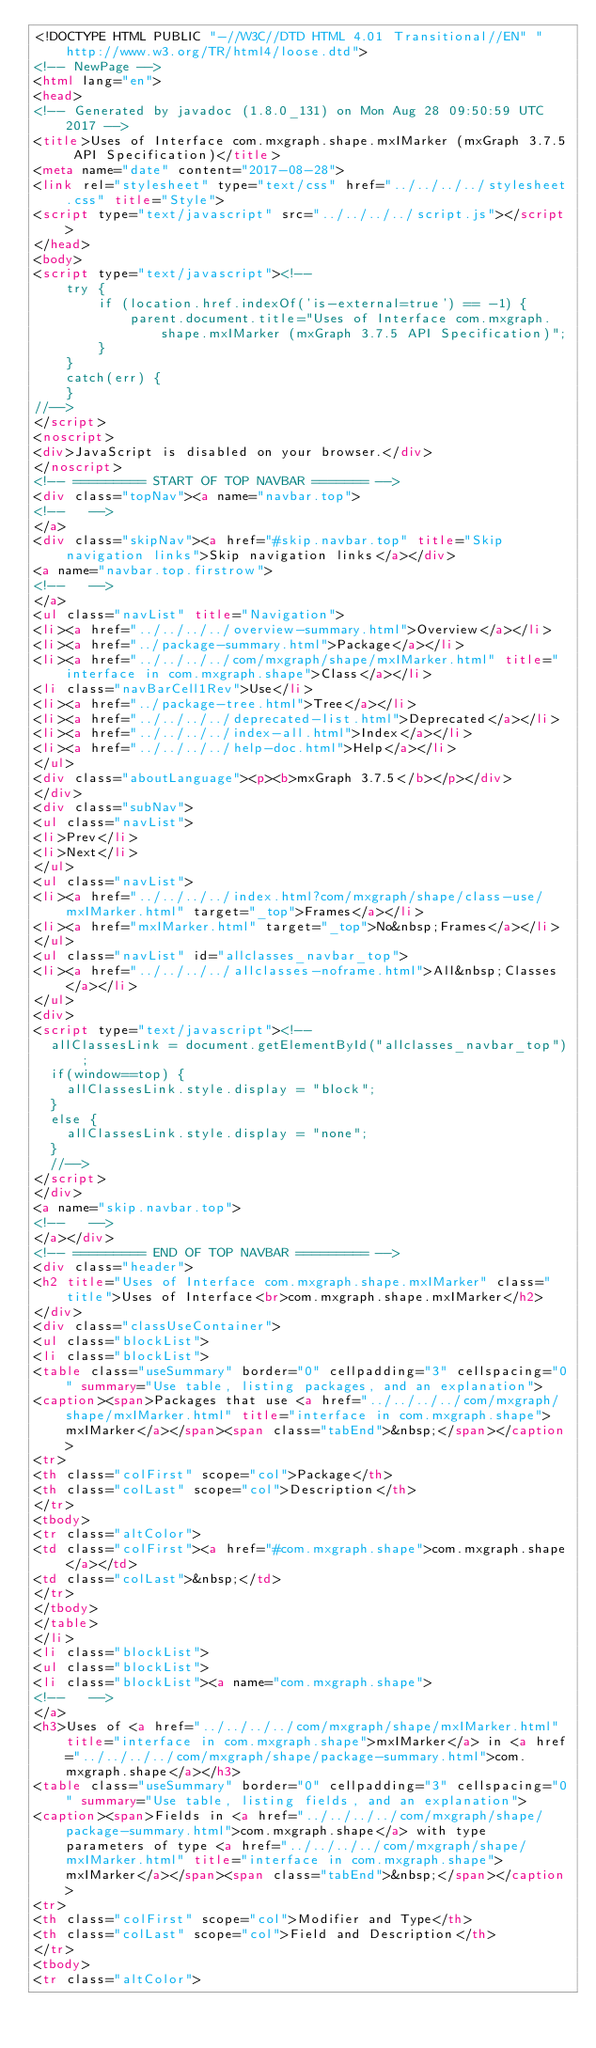Convert code to text. <code><loc_0><loc_0><loc_500><loc_500><_HTML_><!DOCTYPE HTML PUBLIC "-//W3C//DTD HTML 4.01 Transitional//EN" "http://www.w3.org/TR/html4/loose.dtd">
<!-- NewPage -->
<html lang="en">
<head>
<!-- Generated by javadoc (1.8.0_131) on Mon Aug 28 09:50:59 UTC 2017 -->
<title>Uses of Interface com.mxgraph.shape.mxIMarker (mxGraph 3.7.5 API Specification)</title>
<meta name="date" content="2017-08-28">
<link rel="stylesheet" type="text/css" href="../../../../stylesheet.css" title="Style">
<script type="text/javascript" src="../../../../script.js"></script>
</head>
<body>
<script type="text/javascript"><!--
    try {
        if (location.href.indexOf('is-external=true') == -1) {
            parent.document.title="Uses of Interface com.mxgraph.shape.mxIMarker (mxGraph 3.7.5 API Specification)";
        }
    }
    catch(err) {
    }
//-->
</script>
<noscript>
<div>JavaScript is disabled on your browser.</div>
</noscript>
<!-- ========= START OF TOP NAVBAR ======= -->
<div class="topNav"><a name="navbar.top">
<!--   -->
</a>
<div class="skipNav"><a href="#skip.navbar.top" title="Skip navigation links">Skip navigation links</a></div>
<a name="navbar.top.firstrow">
<!--   -->
</a>
<ul class="navList" title="Navigation">
<li><a href="../../../../overview-summary.html">Overview</a></li>
<li><a href="../package-summary.html">Package</a></li>
<li><a href="../../../../com/mxgraph/shape/mxIMarker.html" title="interface in com.mxgraph.shape">Class</a></li>
<li class="navBarCell1Rev">Use</li>
<li><a href="../package-tree.html">Tree</a></li>
<li><a href="../../../../deprecated-list.html">Deprecated</a></li>
<li><a href="../../../../index-all.html">Index</a></li>
<li><a href="../../../../help-doc.html">Help</a></li>
</ul>
<div class="aboutLanguage"><p><b>mxGraph 3.7.5</b></p></div>
</div>
<div class="subNav">
<ul class="navList">
<li>Prev</li>
<li>Next</li>
</ul>
<ul class="navList">
<li><a href="../../../../index.html?com/mxgraph/shape/class-use/mxIMarker.html" target="_top">Frames</a></li>
<li><a href="mxIMarker.html" target="_top">No&nbsp;Frames</a></li>
</ul>
<ul class="navList" id="allclasses_navbar_top">
<li><a href="../../../../allclasses-noframe.html">All&nbsp;Classes</a></li>
</ul>
<div>
<script type="text/javascript"><!--
  allClassesLink = document.getElementById("allclasses_navbar_top");
  if(window==top) {
    allClassesLink.style.display = "block";
  }
  else {
    allClassesLink.style.display = "none";
  }
  //-->
</script>
</div>
<a name="skip.navbar.top">
<!--   -->
</a></div>
<!-- ========= END OF TOP NAVBAR ========= -->
<div class="header">
<h2 title="Uses of Interface com.mxgraph.shape.mxIMarker" class="title">Uses of Interface<br>com.mxgraph.shape.mxIMarker</h2>
</div>
<div class="classUseContainer">
<ul class="blockList">
<li class="blockList">
<table class="useSummary" border="0" cellpadding="3" cellspacing="0" summary="Use table, listing packages, and an explanation">
<caption><span>Packages that use <a href="../../../../com/mxgraph/shape/mxIMarker.html" title="interface in com.mxgraph.shape">mxIMarker</a></span><span class="tabEnd">&nbsp;</span></caption>
<tr>
<th class="colFirst" scope="col">Package</th>
<th class="colLast" scope="col">Description</th>
</tr>
<tbody>
<tr class="altColor">
<td class="colFirst"><a href="#com.mxgraph.shape">com.mxgraph.shape</a></td>
<td class="colLast">&nbsp;</td>
</tr>
</tbody>
</table>
</li>
<li class="blockList">
<ul class="blockList">
<li class="blockList"><a name="com.mxgraph.shape">
<!--   -->
</a>
<h3>Uses of <a href="../../../../com/mxgraph/shape/mxIMarker.html" title="interface in com.mxgraph.shape">mxIMarker</a> in <a href="../../../../com/mxgraph/shape/package-summary.html">com.mxgraph.shape</a></h3>
<table class="useSummary" border="0" cellpadding="3" cellspacing="0" summary="Use table, listing fields, and an explanation">
<caption><span>Fields in <a href="../../../../com/mxgraph/shape/package-summary.html">com.mxgraph.shape</a> with type parameters of type <a href="../../../../com/mxgraph/shape/mxIMarker.html" title="interface in com.mxgraph.shape">mxIMarker</a></span><span class="tabEnd">&nbsp;</span></caption>
<tr>
<th class="colFirst" scope="col">Modifier and Type</th>
<th class="colLast" scope="col">Field and Description</th>
</tr>
<tbody>
<tr class="altColor"></code> 